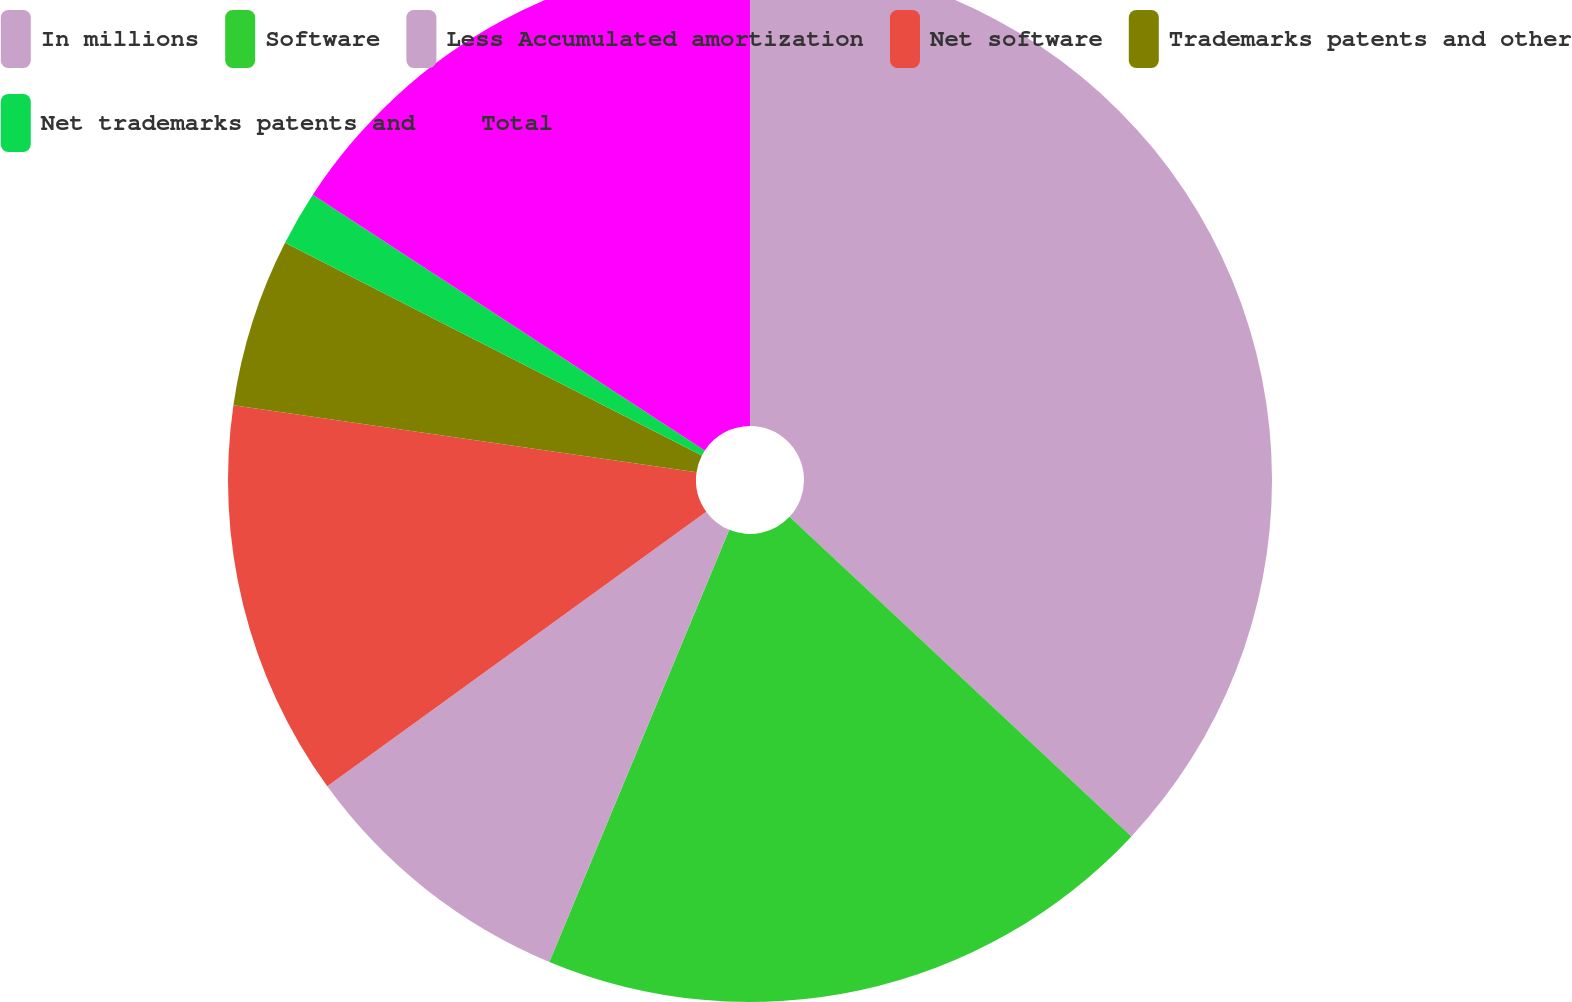Convert chart. <chart><loc_0><loc_0><loc_500><loc_500><pie_chart><fcel>In millions<fcel>Software<fcel>Less Accumulated amortization<fcel>Net software<fcel>Trademarks patents and other<fcel>Net trademarks patents and<fcel>Total<nl><fcel>36.96%<fcel>19.32%<fcel>8.74%<fcel>12.27%<fcel>5.22%<fcel>1.69%<fcel>15.8%<nl></chart> 